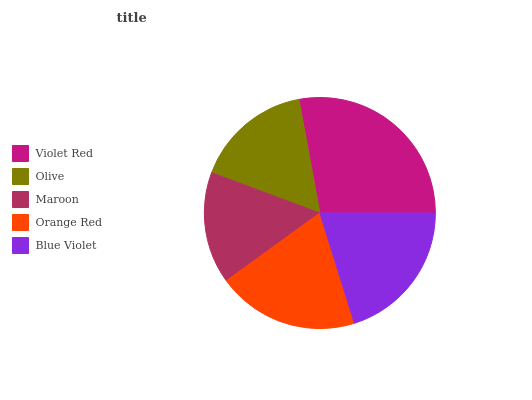Is Maroon the minimum?
Answer yes or no. Yes. Is Violet Red the maximum?
Answer yes or no. Yes. Is Olive the minimum?
Answer yes or no. No. Is Olive the maximum?
Answer yes or no. No. Is Violet Red greater than Olive?
Answer yes or no. Yes. Is Olive less than Violet Red?
Answer yes or no. Yes. Is Olive greater than Violet Red?
Answer yes or no. No. Is Violet Red less than Olive?
Answer yes or no. No. Is Orange Red the high median?
Answer yes or no. Yes. Is Orange Red the low median?
Answer yes or no. Yes. Is Violet Red the high median?
Answer yes or no. No. Is Violet Red the low median?
Answer yes or no. No. 